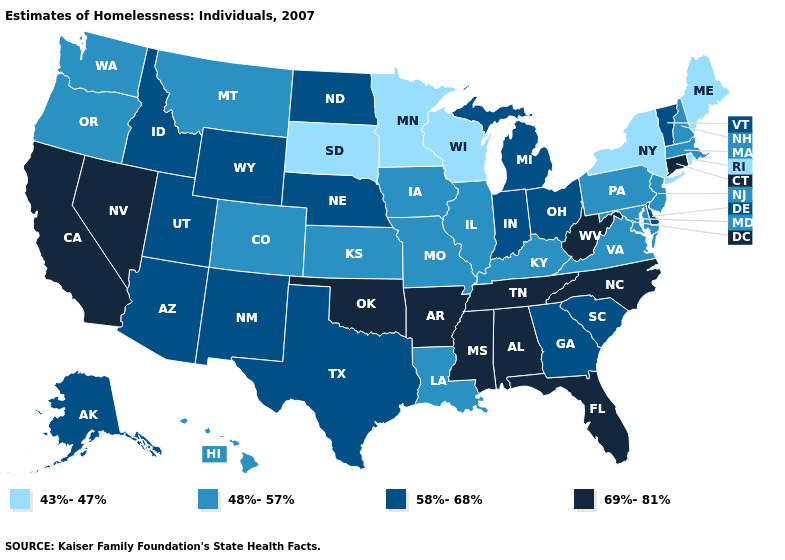What is the value of New Mexico?
Keep it brief. 58%-68%. What is the highest value in the Northeast ?
Keep it brief. 69%-81%. What is the value of Tennessee?
Quick response, please. 69%-81%. Does the map have missing data?
Write a very short answer. No. How many symbols are there in the legend?
Keep it brief. 4. How many symbols are there in the legend?
Give a very brief answer. 4. Does Iowa have a higher value than Kansas?
Keep it brief. No. Does Nevada have the highest value in the USA?
Be succinct. Yes. Name the states that have a value in the range 48%-57%?
Answer briefly. Colorado, Hawaii, Illinois, Iowa, Kansas, Kentucky, Louisiana, Maryland, Massachusetts, Missouri, Montana, New Hampshire, New Jersey, Oregon, Pennsylvania, Virginia, Washington. How many symbols are there in the legend?
Quick response, please. 4. What is the value of New Jersey?
Short answer required. 48%-57%. What is the value of Ohio?
Be succinct. 58%-68%. Does the first symbol in the legend represent the smallest category?
Answer briefly. Yes. What is the highest value in the USA?
Write a very short answer. 69%-81%. Does New York have the lowest value in the USA?
Short answer required. Yes. 